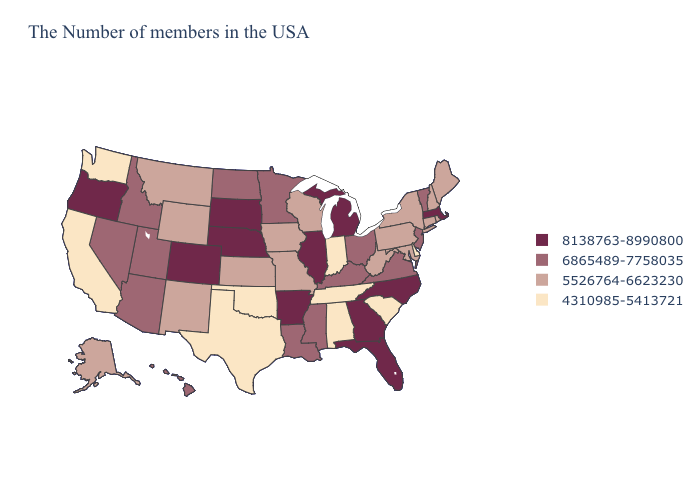Is the legend a continuous bar?
Give a very brief answer. No. Name the states that have a value in the range 4310985-5413721?
Keep it brief. Delaware, South Carolina, Indiana, Alabama, Tennessee, Oklahoma, Texas, California, Washington. Name the states that have a value in the range 4310985-5413721?
Be succinct. Delaware, South Carolina, Indiana, Alabama, Tennessee, Oklahoma, Texas, California, Washington. What is the highest value in the South ?
Write a very short answer. 8138763-8990800. What is the highest value in the USA?
Give a very brief answer. 8138763-8990800. What is the highest value in the USA?
Answer briefly. 8138763-8990800. What is the value of South Dakota?
Give a very brief answer. 8138763-8990800. Does the map have missing data?
Write a very short answer. No. Does North Dakota have the highest value in the MidWest?
Keep it brief. No. Among the states that border Louisiana , which have the highest value?
Keep it brief. Arkansas. What is the value of Louisiana?
Be succinct. 6865489-7758035. Name the states that have a value in the range 8138763-8990800?
Write a very short answer. Massachusetts, North Carolina, Florida, Georgia, Michigan, Illinois, Arkansas, Nebraska, South Dakota, Colorado, Oregon. Among the states that border Alabama , does Florida have the highest value?
Answer briefly. Yes. Does the map have missing data?
Short answer required. No. Does Oregon have the same value as Ohio?
Give a very brief answer. No. 